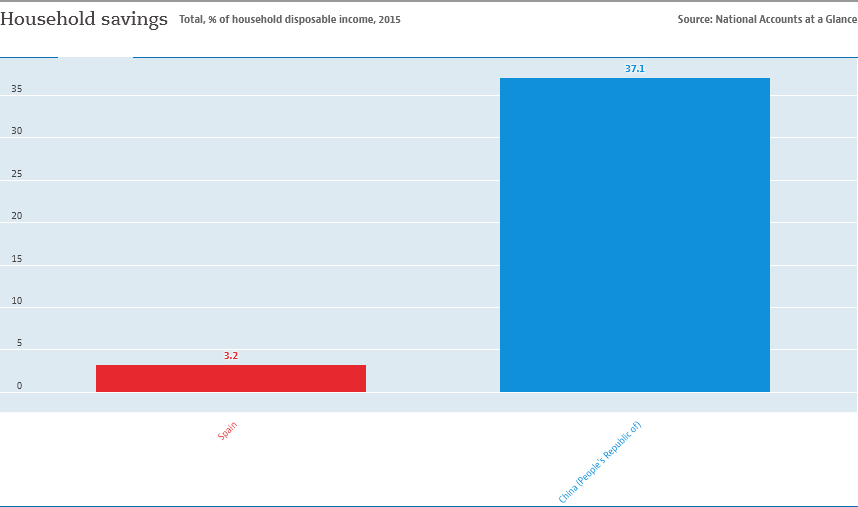Outline some significant characteristics in this image. The color bar that represents Spain is red. What differentiates these two bars? 33.9... 